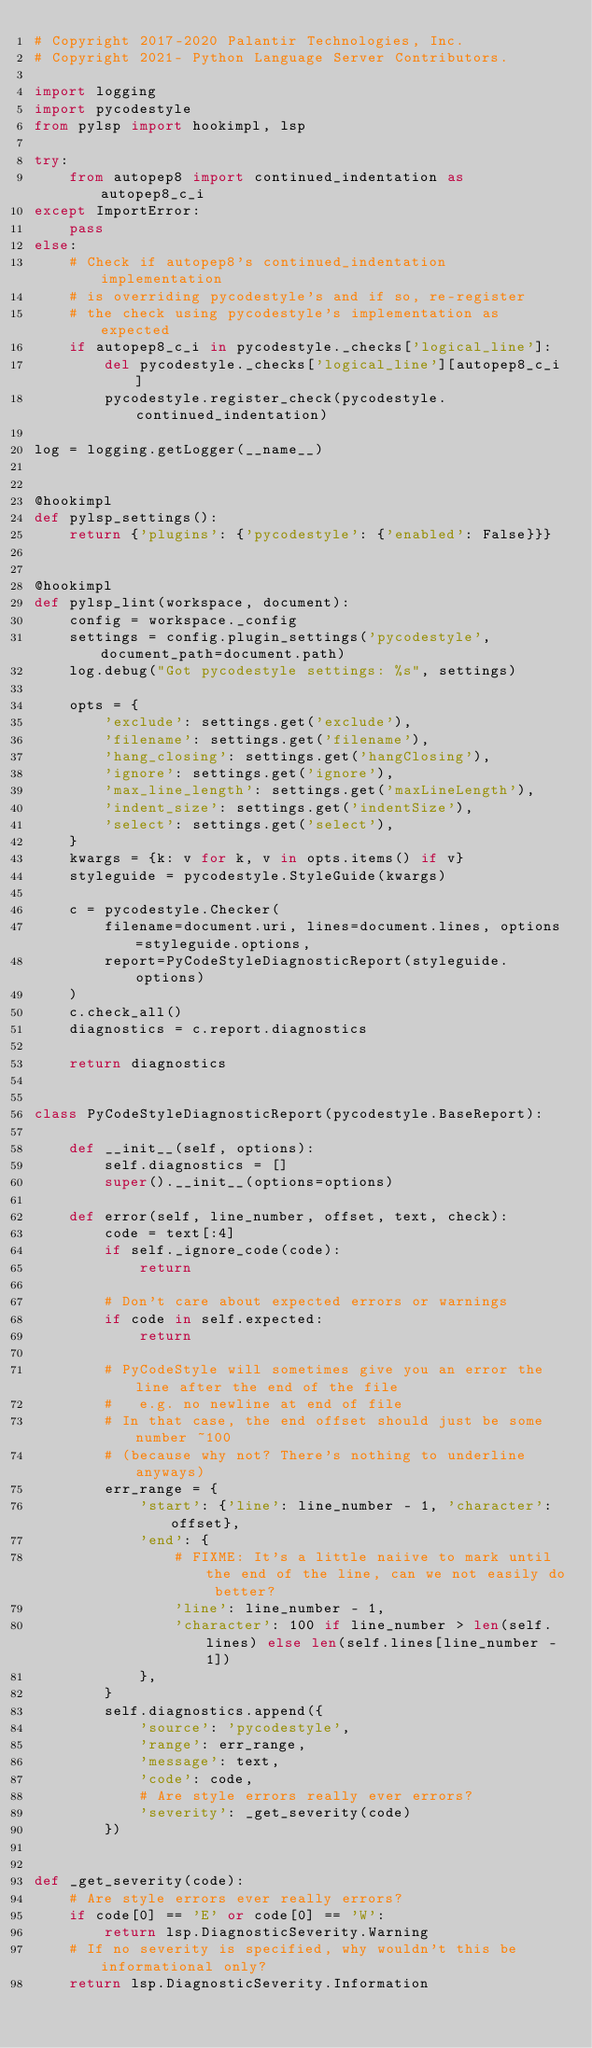<code> <loc_0><loc_0><loc_500><loc_500><_Python_># Copyright 2017-2020 Palantir Technologies, Inc.
# Copyright 2021- Python Language Server Contributors.

import logging
import pycodestyle
from pylsp import hookimpl, lsp

try:
    from autopep8 import continued_indentation as autopep8_c_i
except ImportError:
    pass
else:
    # Check if autopep8's continued_indentation implementation
    # is overriding pycodestyle's and if so, re-register
    # the check using pycodestyle's implementation as expected
    if autopep8_c_i in pycodestyle._checks['logical_line']:
        del pycodestyle._checks['logical_line'][autopep8_c_i]
        pycodestyle.register_check(pycodestyle.continued_indentation)

log = logging.getLogger(__name__)


@hookimpl
def pylsp_settings():
    return {'plugins': {'pycodestyle': {'enabled': False}}}


@hookimpl
def pylsp_lint(workspace, document):
    config = workspace._config
    settings = config.plugin_settings('pycodestyle', document_path=document.path)
    log.debug("Got pycodestyle settings: %s", settings)

    opts = {
        'exclude': settings.get('exclude'),
        'filename': settings.get('filename'),
        'hang_closing': settings.get('hangClosing'),
        'ignore': settings.get('ignore'),
        'max_line_length': settings.get('maxLineLength'),
        'indent_size': settings.get('indentSize'),
        'select': settings.get('select'),
    }
    kwargs = {k: v for k, v in opts.items() if v}
    styleguide = pycodestyle.StyleGuide(kwargs)

    c = pycodestyle.Checker(
        filename=document.uri, lines=document.lines, options=styleguide.options,
        report=PyCodeStyleDiagnosticReport(styleguide.options)
    )
    c.check_all()
    diagnostics = c.report.diagnostics

    return diagnostics


class PyCodeStyleDiagnosticReport(pycodestyle.BaseReport):

    def __init__(self, options):
        self.diagnostics = []
        super().__init__(options=options)

    def error(self, line_number, offset, text, check):
        code = text[:4]
        if self._ignore_code(code):
            return

        # Don't care about expected errors or warnings
        if code in self.expected:
            return

        # PyCodeStyle will sometimes give you an error the line after the end of the file
        #   e.g. no newline at end of file
        # In that case, the end offset should just be some number ~100
        # (because why not? There's nothing to underline anyways)
        err_range = {
            'start': {'line': line_number - 1, 'character': offset},
            'end': {
                # FIXME: It's a little naiive to mark until the end of the line, can we not easily do better?
                'line': line_number - 1,
                'character': 100 if line_number > len(self.lines) else len(self.lines[line_number - 1])
            },
        }
        self.diagnostics.append({
            'source': 'pycodestyle',
            'range': err_range,
            'message': text,
            'code': code,
            # Are style errors really ever errors?
            'severity': _get_severity(code)
        })


def _get_severity(code):
    # Are style errors ever really errors?
    if code[0] == 'E' or code[0] == 'W':
        return lsp.DiagnosticSeverity.Warning
    # If no severity is specified, why wouldn't this be informational only?
    return lsp.DiagnosticSeverity.Information
</code> 